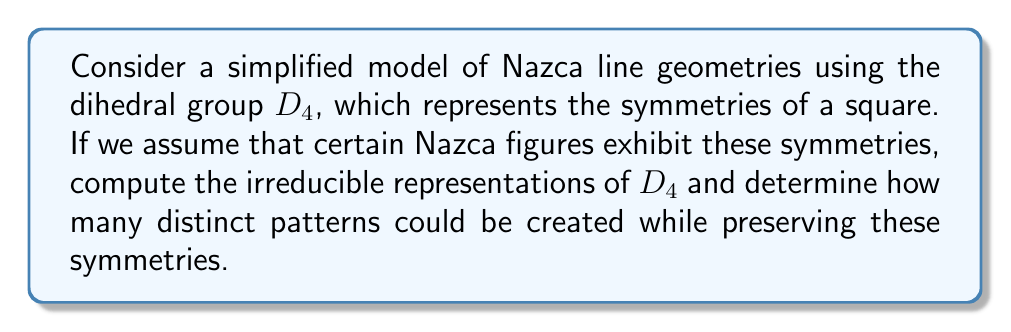Solve this math problem. Let's approach this step-by-step:

1) First, recall that $D_4$ has 8 elements: rotations by 0°, 90°, 180°, 270°, and four reflections (two diagonal and two across the midlines).

2) To find the irreducible representations, we need to determine the conjugacy classes:
   - $\{e\}$ (identity)
   - $\{r^2\}$ (rotation by 180°)
   - $\{r, r^3\}$ (rotations by 90° and 270°)
   - $\{s, sr^2\}$ (reflections across midlines)
   - $\{sr, sr^3\}$ (reflections across diagonals)

3) The number of irreducible representations equals the number of conjugacy classes, so we have 5 irreducible representations.

4) We know that $\sum_{i=1}^5 d_i^2 = |D_4| = 8$, where $d_i$ are the dimensions of the irreducible representations.

5) Given the structure of $D_4$, we can deduce that there are four 1-dimensional representations and one 2-dimensional representation:
   - $\chi_1$: trivial representation
   - $\chi_2$: sign representation for rotations
   - $\chi_3$: sign representation for horizontal/vertical reflections
   - $\chi_4$: sign representation for diagonal reflections
   - $\chi_5$: 2-dimensional representation

6) The character table for $D_4$ is:

   $$\begin{array}{c|ccccc}
      & \{e\} & \{r^2\} & \{r,r^3\} & \{s,sr^2\} & \{sr,sr^3\} \\
   \hline
   \chi_1 & 1 & 1 & 1 & 1 & 1 \\
   \chi_2 & 1 & 1 & -1 & 1 & -1 \\
   \chi_3 & 1 & 1 & -1 & -1 & 1 \\
   \chi_4 & 1 & 1 & 1 & -1 & -1 \\
   \chi_5 & 2 & -2 & 0 & 0 & 0
   \end{array}$$

7) Each irreducible representation corresponds to a distinct pattern that preserves the symmetries of $D_4$. Therefore, there are 5 distinct patterns possible.

[asy]
size(200);
draw((-1,-1)--(1,-1)--(1,1)--(-1,1)--cycle);
draw((-1,-1)--(1,1));
draw((1,-1)--(-1,1));
draw((-1,0)--(1,0));
draw((0,-1)--(0,1));
label("$e$", (0,0));
label("$r$", (0.7,0.7));
label("$r^2$", (0,0.7));
label("$r^3$", (-0.7,0.7));
label("$s$", (0.7,0));
label("$sr$", (0.7,-0.7));
label("$sr^2$", (-0.7,0));
label("$sr^3$", (-0.7,-0.7));
[/asy]

This diagram illustrates the symmetries of $D_4$, which we've used to model the Nazca line geometries.
Answer: 5 irreducible representations: four 1-dimensional and one 2-dimensional, allowing for 5 distinct symmetric patterns. 